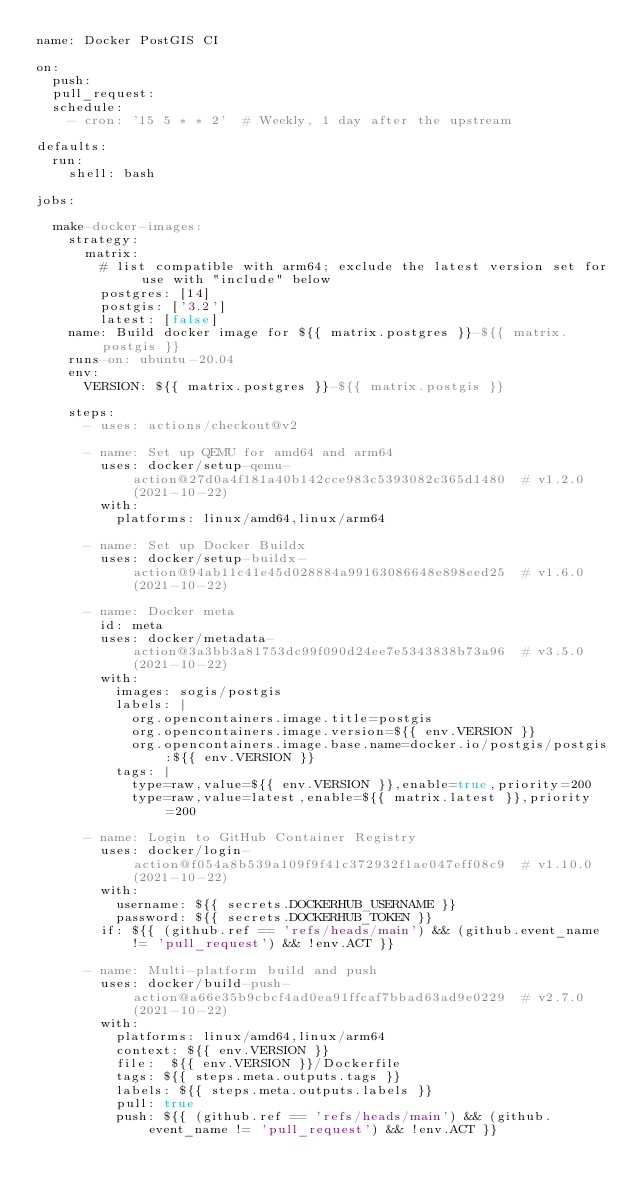<code> <loc_0><loc_0><loc_500><loc_500><_YAML_>name: Docker PostGIS CI

on:
  push:
  pull_request:
  schedule:
    - cron: '15 5 * * 2'  # Weekly, 1 day after the upstream

defaults:
  run:
    shell: bash

jobs:

  make-docker-images:
    strategy:
      matrix:
        # list compatible with arm64; exclude the latest version set for use with "include" below
        postgres: [14]
        postgis: ['3.2']
        latest: [false]
    name: Build docker image for ${{ matrix.postgres }}-${{ matrix.postgis }}
    runs-on: ubuntu-20.04
    env:
      VERSION: ${{ matrix.postgres }}-${{ matrix.postgis }}

    steps:
      - uses: actions/checkout@v2

      - name: Set up QEMU for amd64 and arm64
        uses: docker/setup-qemu-action@27d0a4f181a40b142cce983c5393082c365d1480  # v1.2.0 (2021-10-22)
        with:
          platforms: linux/amd64,linux/arm64

      - name: Set up Docker Buildx
        uses: docker/setup-buildx-action@94ab11c41e45d028884a99163086648e898eed25  # v1.6.0 (2021-10-22)

      - name: Docker meta
        id: meta
        uses: docker/metadata-action@3a3bb3a81753dc99f090d24ee7e5343838b73a96  # v3.5.0 (2021-10-22)
        with:
          images: sogis/postgis
          labels: |
            org.opencontainers.image.title=postgis
            org.opencontainers.image.version=${{ env.VERSION }}
            org.opencontainers.image.base.name=docker.io/postgis/postgis:${{ env.VERSION }}
          tags: |
            type=raw,value=${{ env.VERSION }},enable=true,priority=200
            type=raw,value=latest,enable=${{ matrix.latest }},priority=200

      - name: Login to GitHub Container Registry
        uses: docker/login-action@f054a8b539a109f9f41c372932f1ae047eff08c9  # v1.10.0 (2021-10-22)
        with:
          username: ${{ secrets.DOCKERHUB_USERNAME }}
          password: ${{ secrets.DOCKERHUB_TOKEN }}
        if: ${{ (github.ref == 'refs/heads/main') && (github.event_name != 'pull_request') && !env.ACT }}

      - name: Multi-platform build and push
        uses: docker/build-push-action@a66e35b9cbcf4ad0ea91ffcaf7bbad63ad9e0229  # v2.7.0 (2021-10-22)
        with:
          platforms: linux/amd64,linux/arm64
          context: ${{ env.VERSION }}
          file:  ${{ env.VERSION }}/Dockerfile
          tags: ${{ steps.meta.outputs.tags }}
          labels: ${{ steps.meta.outputs.labels }}
          pull: true
          push: ${{ (github.ref == 'refs/heads/main') && (github.event_name != 'pull_request') && !env.ACT }}</code> 